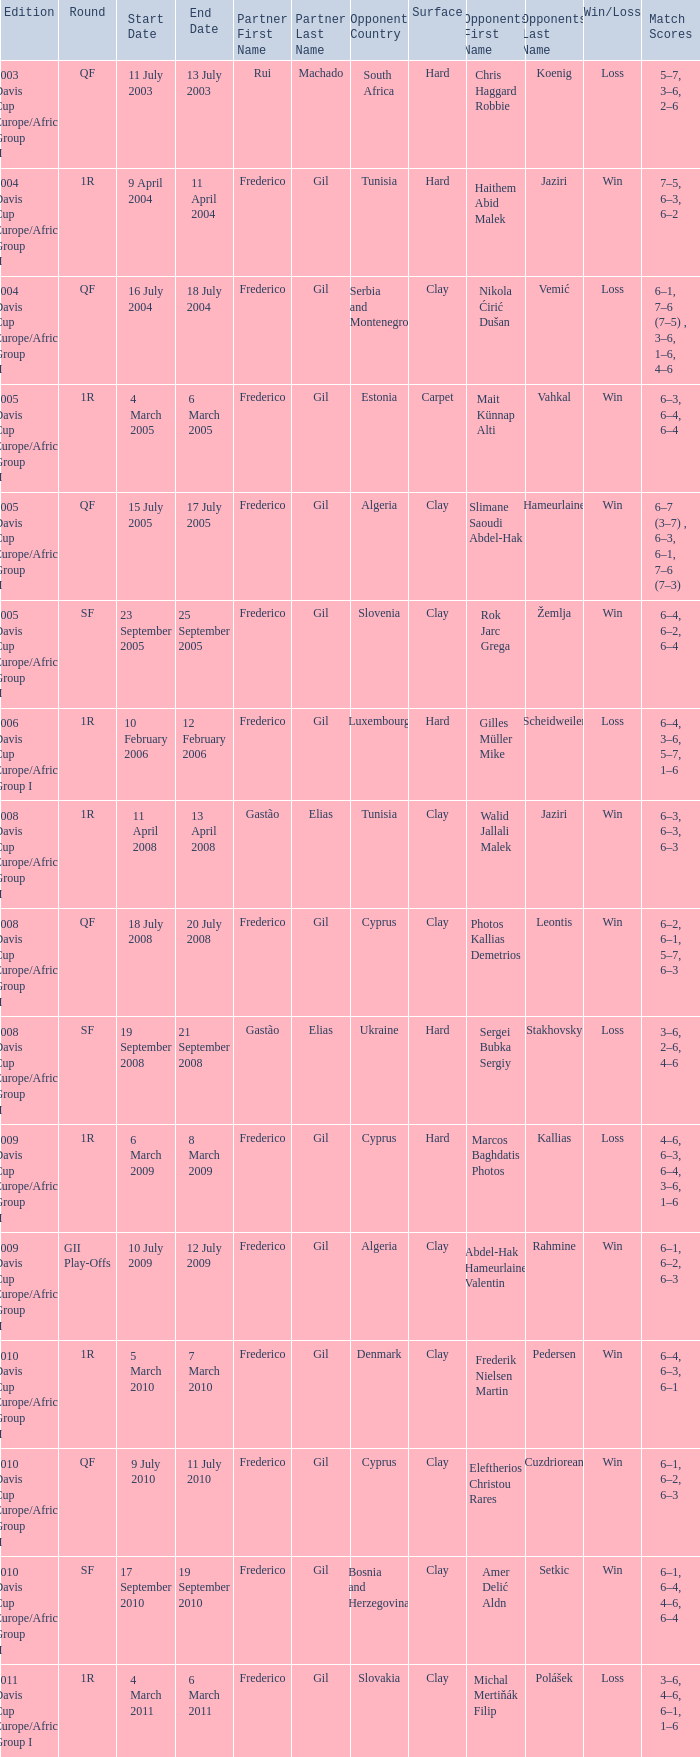How many rounds were there in the 2006 davis cup europe/africa group I? 1.0. 